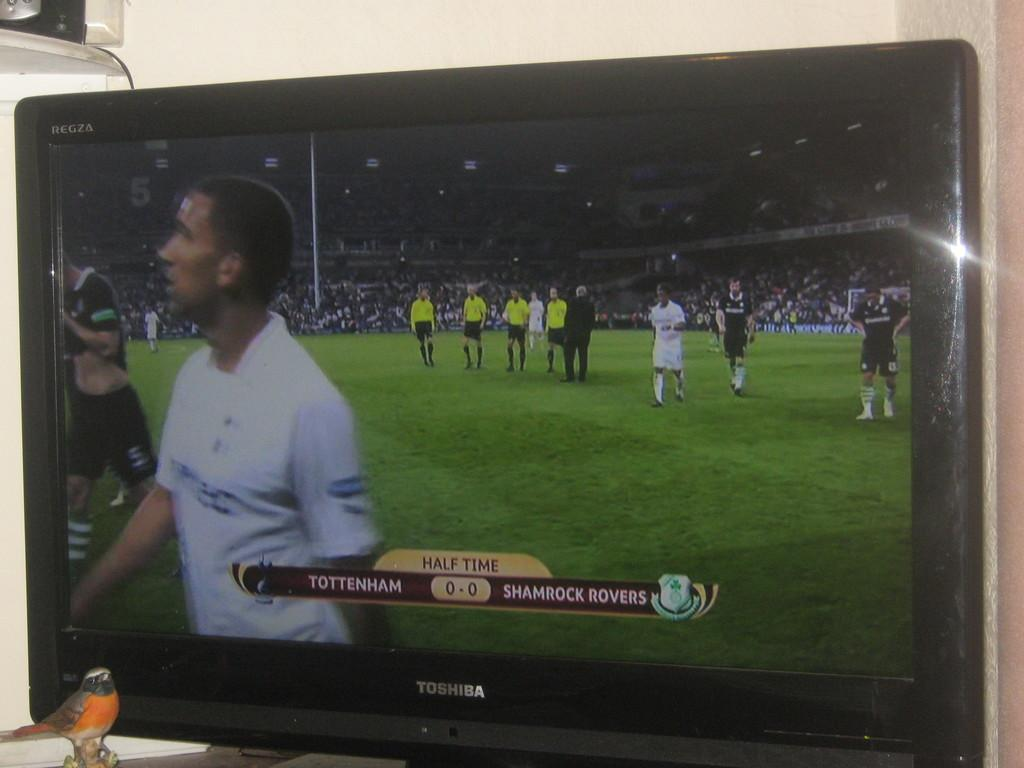<image>
Write a terse but informative summary of the picture. A picture of a television showing the half time score of a Tottenham v Shamrock Rovers soccer match. 